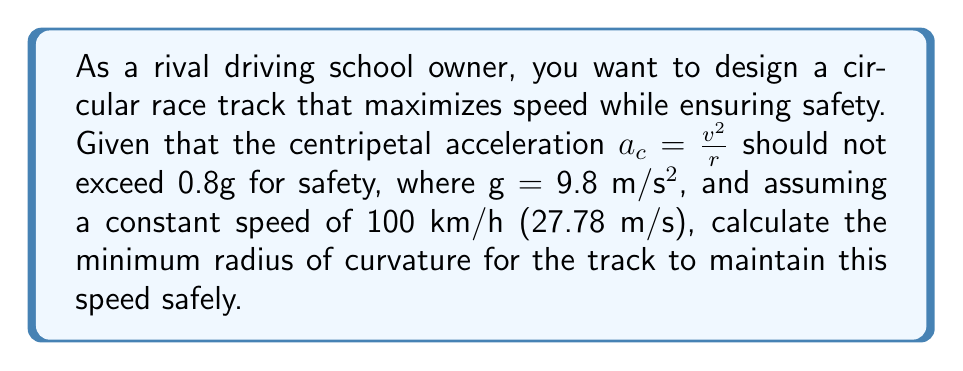Can you answer this question? Let's approach this step-by-step:

1) We're given:
   - Maximum centripetal acceleration: $a_c = 0.8g = 0.8 \times 9.8 = 7.84$ m/s²
   - Speed: $v = 100$ km/h = 27.78 m/s
   - Formula for centripetal acceleration: $a_c = \frac{v^2}{r}$

2) We need to find the minimum radius $r$. Let's rearrange the formula:

   $$r = \frac{v^2}{a_c}$$

3) Now, let's substitute the values:

   $$r = \frac{(27.78 \text{ m/s})^2}{7.84 \text{ m/s}^2}$$

4) Calculate:

   $$r = \frac{771.73 \text{ m}^2/\text{s}^2}{7.84 \text{ m}/\text{s}^2} = 98.44 \text{ m}$$

5) Round to two decimal places for practical use:

   $$r \approx 98.44 \text{ m}$$

Therefore, the minimum radius of curvature for the track should be approximately 98.44 meters to safely maintain a speed of 100 km/h.
Answer: 98.44 m 